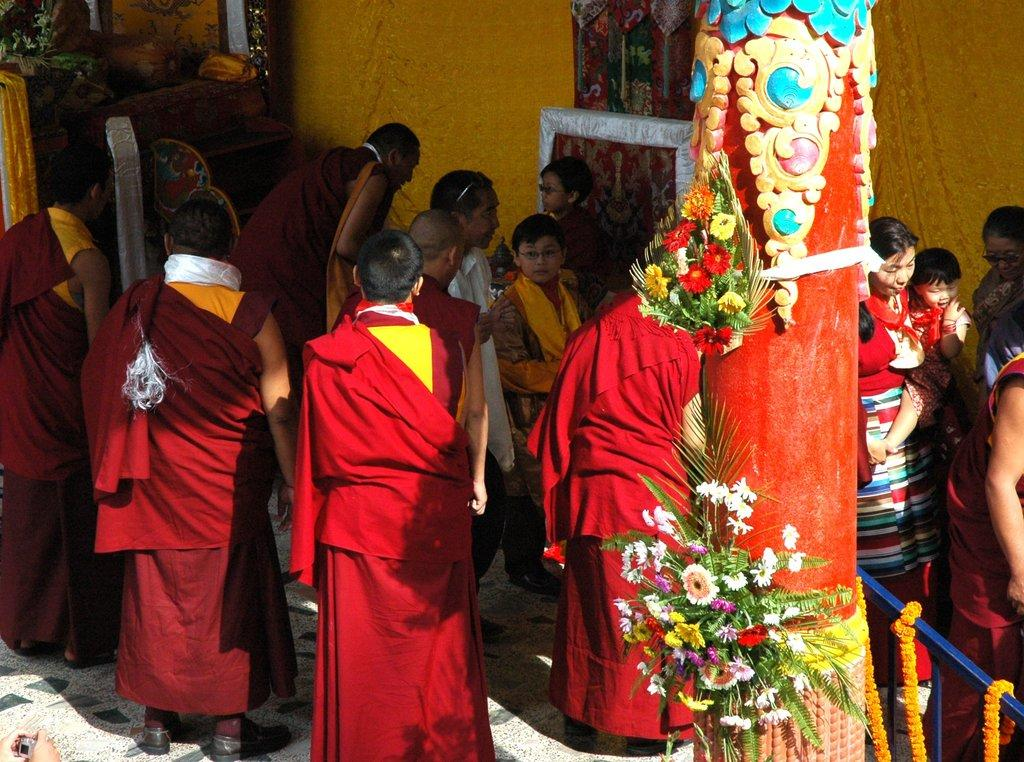Who or what can be seen in the image? There are people in the image. What is attached to the pillar in the image? There are flowers attached to a pillar in the image. What type of barrier is present in the image? There is a fence in the image. How is the fence decorated? The fence is decorated with garland in the image. What type of vegetation is present in the image? There are plants in the image. What type of hobbies do the people in the image enjoy? The provided facts do not give any information about the hobbies of the people in the image. --- Facts: 1. There is a car in the image. 2. The car is parked on the street. 3. There are trees in the background. 4. The sky is visible in the image. 5. The car has a red color. Absurd Topics: dance, ocean, birdhouse Conversation: What vehicle is present in the image? There is a car in the image. Where is the car located in the image? The car is parked on the street in the image. What type of vegetation can be seen in the background? There are trees in the background of the image. What is visible at the top of the image? The sky is visible in the image. What color is the car in the image? The car has a red color. Reasoning: Let's think step by step in order to produce the conversation. We start by identifying the main subject in the image, which is the car. Then, we expand the conversation to include other details about the image, such as the car's location, the trees in the background, the sky, and the car's color. Each question is designed to elicit a specific detail about the image that is known from the provided facts. Absurd Question/Answer: Can you see any birdhouses in the image? There is no mention of a birdhouse in the provided facts, so it cannot be determined if one is present in the image. 